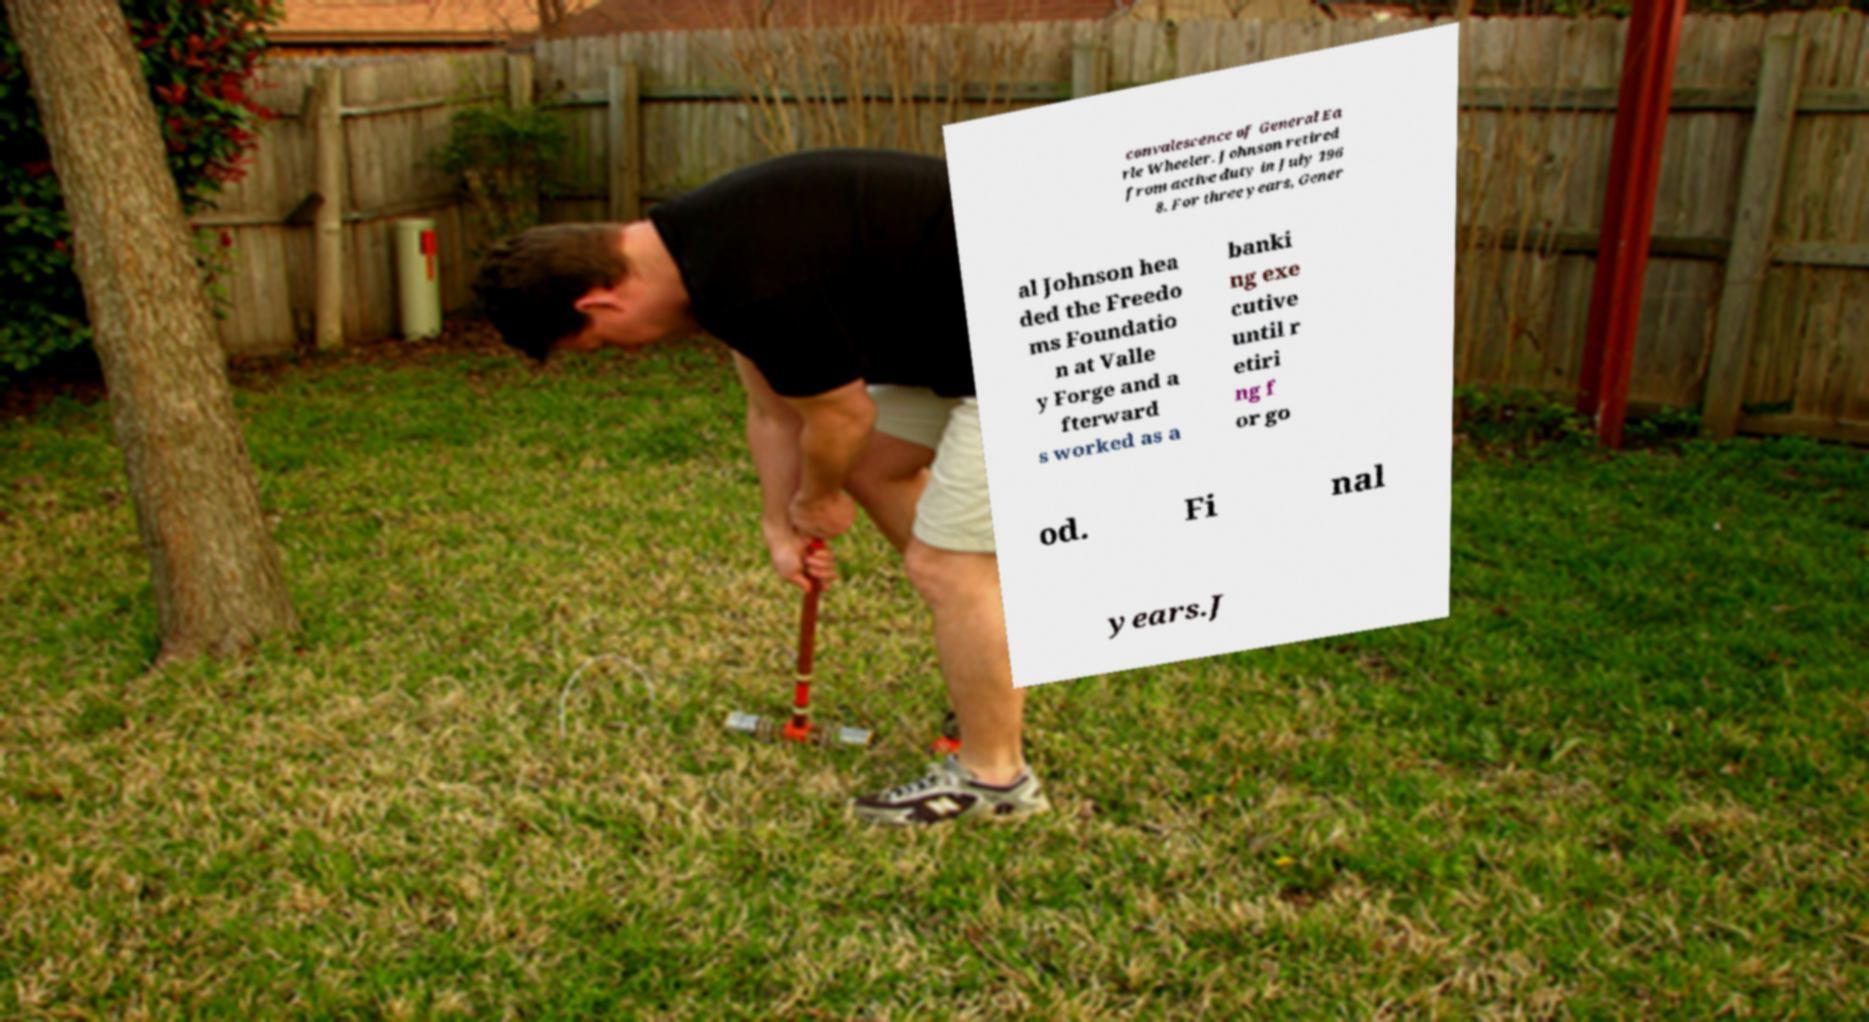Could you assist in decoding the text presented in this image and type it out clearly? convalescence of General Ea rle Wheeler. Johnson retired from active duty in July 196 8. For three years, Gener al Johnson hea ded the Freedo ms Foundatio n at Valle y Forge and a fterward s worked as a banki ng exe cutive until r etiri ng f or go od. Fi nal years.J 